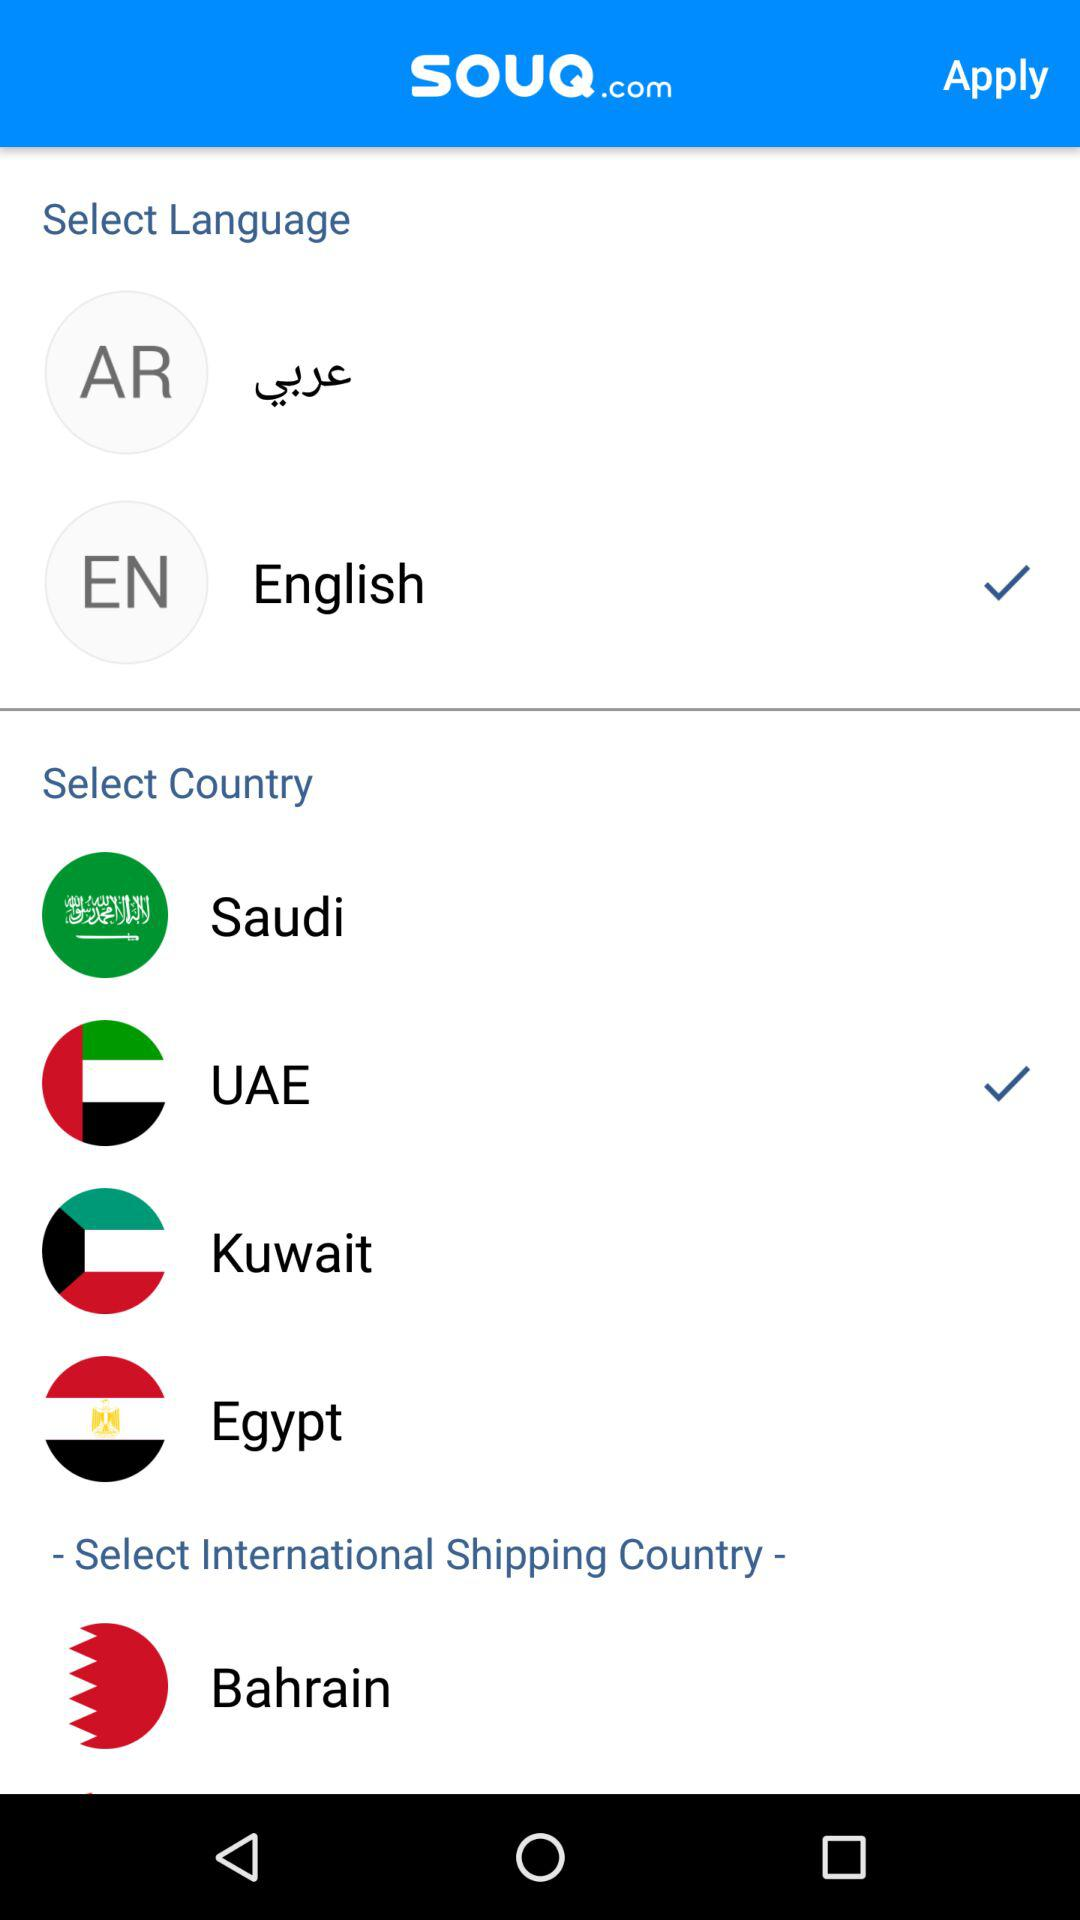What is the selected language? The selected language is English. 